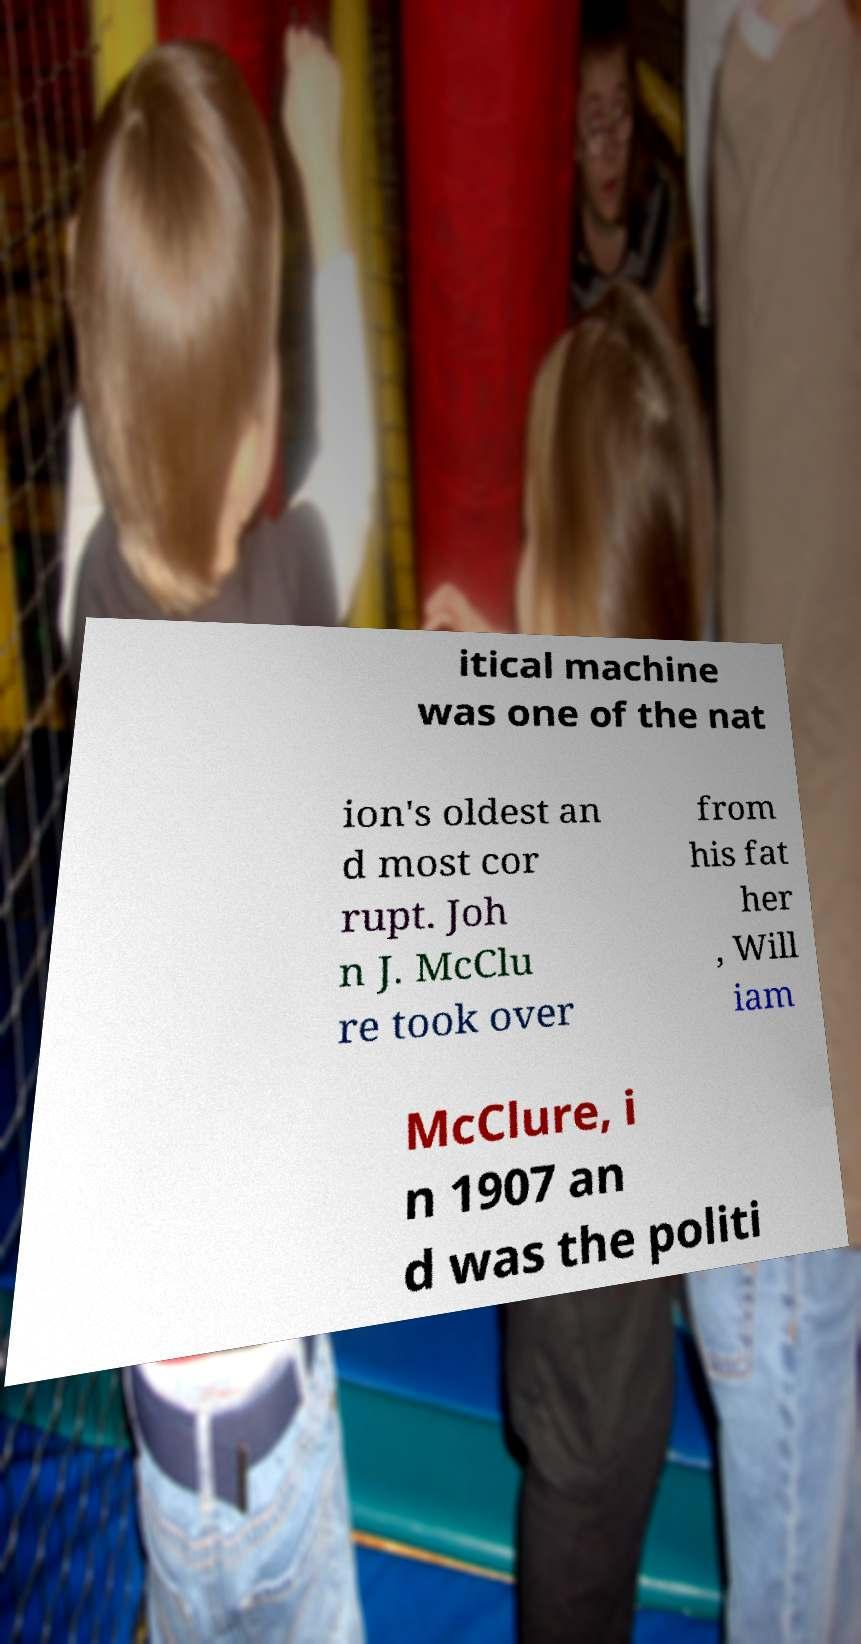I need the written content from this picture converted into text. Can you do that? itical machine was one of the nat ion's oldest an d most cor rupt. Joh n J. McClu re took over from his fat her , Will iam McClure, i n 1907 an d was the politi 